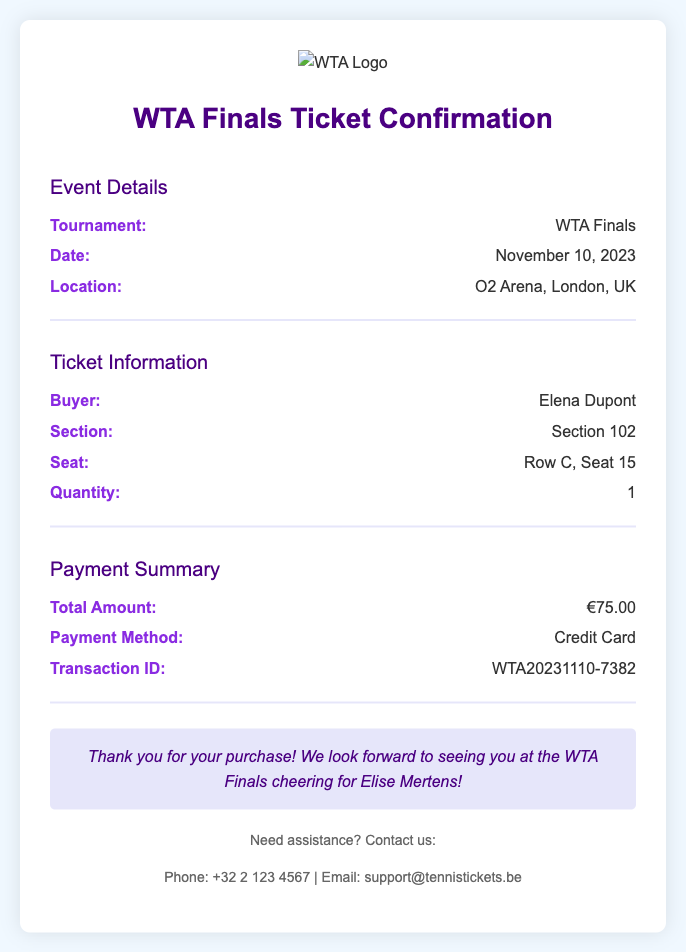what is the tournament name? The tournament name is specified in the event details section of the document.
Answer: WTA Finals what is the date of the event? The date of the event is provided in the event details section.
Answer: November 10, 2023 where is the event located? The location of the event is mentioned in the event details section.
Answer: O2 Arena, London, UK who is the buyer of the ticket? The buyer's name is listed in the ticket information section.
Answer: Elena Dupont what section is the seat located in? The section information is provided in the ticket information section.
Answer: Section 102 how much did the ticket cost? The total amount for the ticket is shown in the payment summary section.
Answer: €75.00 what payment method was used? The payment method is specified in the payment summary section.
Answer: Credit Card what is the transaction ID? The transaction ID can be found in the payment summary section of the document.
Answer: WTA20231110-7382 what confirmation message is included? The confirmation message is a statement at the end of the document thanking the buyer.
Answer: Thank you for your purchase! We look forward to seeing you at the WTA Finals cheering for Elise Mertens! 